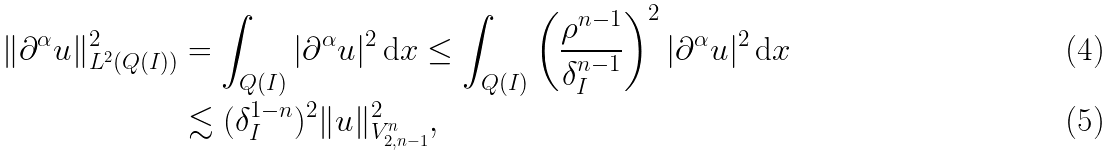Convert formula to latex. <formula><loc_0><loc_0><loc_500><loc_500>\| \partial ^ { \alpha } u \| _ { L ^ { 2 } ( Q ( I ) ) } ^ { 2 } & = \int _ { Q ( I ) } | \partial ^ { \alpha } u | ^ { 2 } \, \mathrm d x \leq \int _ { Q ( I ) } \left ( \frac { \rho ^ { n - 1 } } { \delta _ { I } ^ { n - 1 } } \right ) ^ { 2 } | \partial ^ { \alpha } u | ^ { 2 } \, \mathrm d x \\ & \lesssim ( \delta _ { I } ^ { 1 - n } ) ^ { 2 } \| u \| _ { V ^ { n } _ { 2 , n - 1 } } ^ { 2 } ,</formula> 